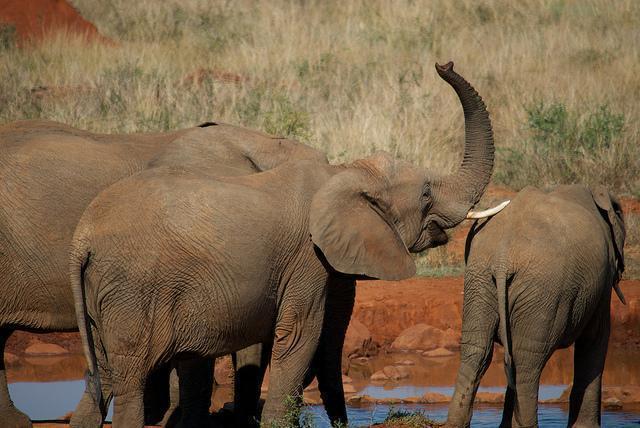What is not unique about this animals?
Choose the right answer and clarify with the format: 'Answer: answer
Rationale: rationale.'
Options: Have husks, large ears, have trunks, four legs. Answer: four legs.
Rationale: Many mammals have four legs and the rest of the items on the list are not as common. 